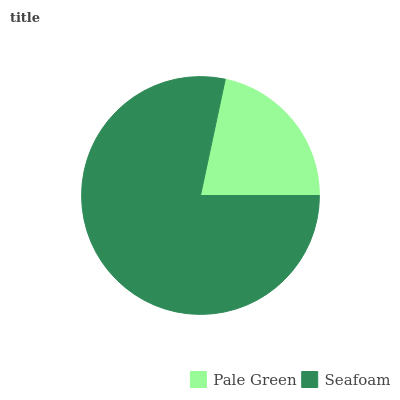Is Pale Green the minimum?
Answer yes or no. Yes. Is Seafoam the maximum?
Answer yes or no. Yes. Is Seafoam the minimum?
Answer yes or no. No. Is Seafoam greater than Pale Green?
Answer yes or no. Yes. Is Pale Green less than Seafoam?
Answer yes or no. Yes. Is Pale Green greater than Seafoam?
Answer yes or no. No. Is Seafoam less than Pale Green?
Answer yes or no. No. Is Seafoam the high median?
Answer yes or no. Yes. Is Pale Green the low median?
Answer yes or no. Yes. Is Pale Green the high median?
Answer yes or no. No. Is Seafoam the low median?
Answer yes or no. No. 